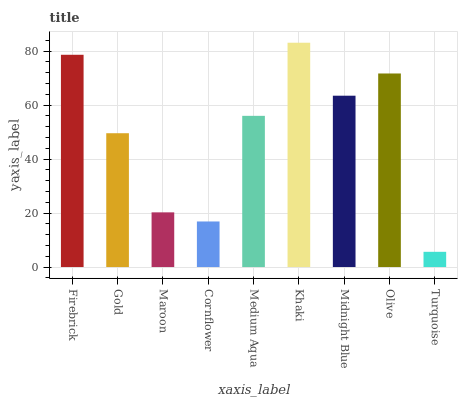Is Turquoise the minimum?
Answer yes or no. Yes. Is Khaki the maximum?
Answer yes or no. Yes. Is Gold the minimum?
Answer yes or no. No. Is Gold the maximum?
Answer yes or no. No. Is Firebrick greater than Gold?
Answer yes or no. Yes. Is Gold less than Firebrick?
Answer yes or no. Yes. Is Gold greater than Firebrick?
Answer yes or no. No. Is Firebrick less than Gold?
Answer yes or no. No. Is Medium Aqua the high median?
Answer yes or no. Yes. Is Medium Aqua the low median?
Answer yes or no. Yes. Is Midnight Blue the high median?
Answer yes or no. No. Is Olive the low median?
Answer yes or no. No. 